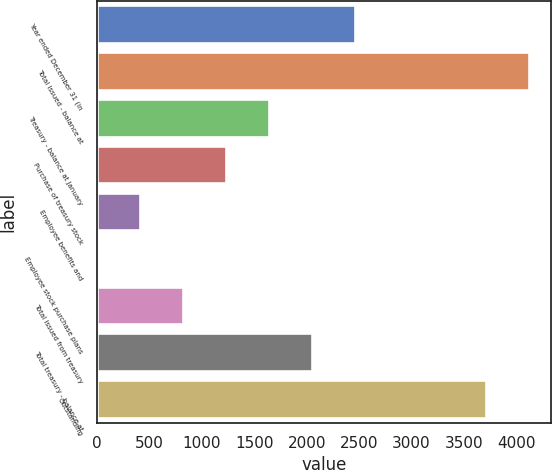<chart> <loc_0><loc_0><loc_500><loc_500><bar_chart><fcel>Year ended December 31 (in<fcel>Total issued - balance at<fcel>Treasury - balance at January<fcel>Purchase of treasury stock<fcel>Employee benefits and<fcel>Employee stock purchase plans<fcel>Total issued from treasury<fcel>Total treasury - balance at<fcel>Outstanding<nl><fcel>2463.42<fcel>4125.17<fcel>1642.68<fcel>1232.31<fcel>411.57<fcel>1.2<fcel>821.94<fcel>2053.05<fcel>3714.8<nl></chart> 